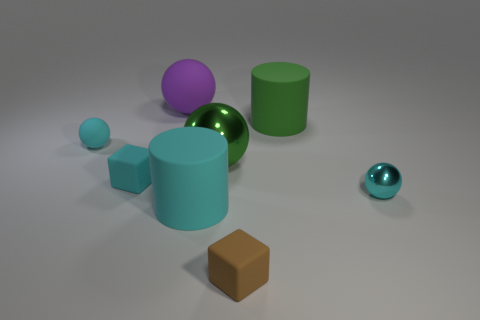Is the number of cyan objects that are right of the small cyan matte ball greater than the number of purple matte objects on the right side of the large purple matte thing?
Your response must be concise. Yes. Is the cyan cube the same size as the cyan rubber cylinder?
Provide a succinct answer. No. What color is the big rubber cylinder behind the large cyan cylinder in front of the cyan cube?
Give a very brief answer. Green. What color is the small shiny ball?
Offer a very short reply. Cyan. Are there any small matte cubes that have the same color as the large rubber sphere?
Your answer should be compact. No. Do the small object that is on the right side of the green rubber cylinder and the tiny matte ball have the same color?
Your answer should be very brief. Yes. How many things are cyan balls right of the brown thing or large cyan matte blocks?
Offer a terse response. 1. Are there any green shiny things left of the cyan cylinder?
Your response must be concise. No. What is the material of the other ball that is the same color as the tiny matte ball?
Offer a terse response. Metal. Is the material of the big cylinder that is behind the big green metallic thing the same as the green sphere?
Your answer should be compact. No. 